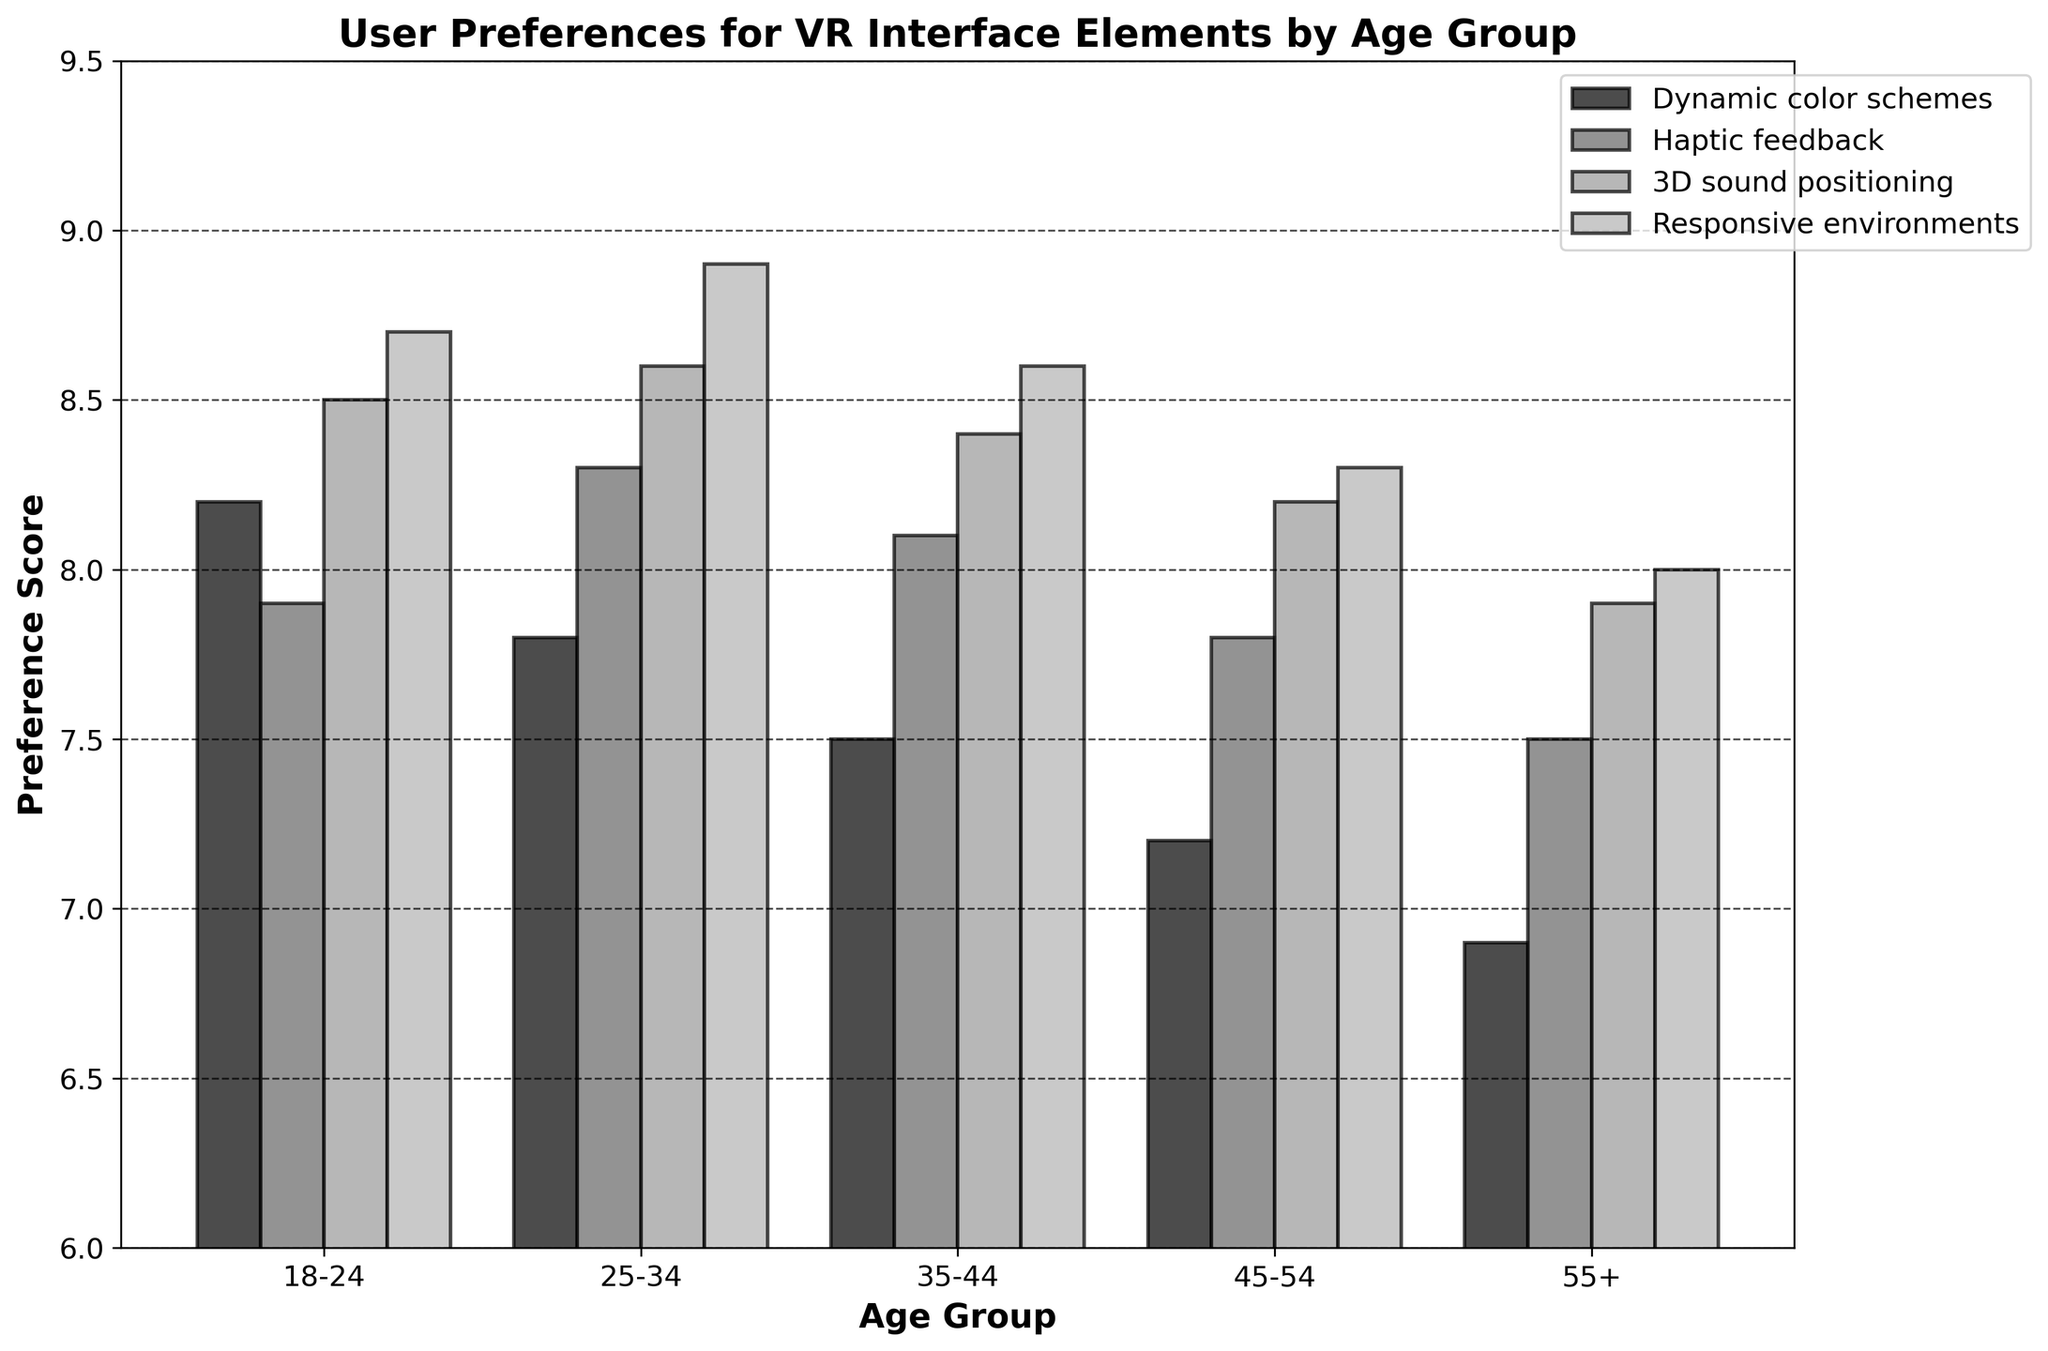Which age group has the lowest preference score for Dynamic color schemes? Look at the bars representing "Dynamic color schemes" across all age groups. The bar for the 55+ age group is the shortest.
Answer: 55+ Which interface element has the highest preference score among the 25-34 age group? Observe the bars corresponding to different interface elements for the 25-34 age group. The tallest bar represents "Responsive environments."
Answer: Responsive environments What is the difference between the preference scores for Haptic feedback for the age groups 18-24 and 55+? Compare the bars for "Haptic feedback" between these two age groups. The scores are 7.9 for 18-24 and 7.5 for 55+. Subtract 7.5 from 7.9: 7.9 - 7.5 = 0.4
Answer: 0.4 What is the average preference score for 3D sound positioning across all age groups? Add up the preference scores for "3D sound positioning" across all age groups: 8.5 (18-24) + 8.6 (25-34) + 8.4 (35-44) + 8.2 (45-54) + 7.9 (55+). Divide by 5 to find the average: (8.5 + 8.6 + 8.4 + 8.2 + 7.9) / 5 = 8.32
Answer: 8.32 Which age group has the most uniform (i.e., the smallest range) preference scores across all interface elements? Calculate the range (difference between highest and lowest scores) for each age group. For 18-24, the range is 8.7 - 7.9 = 0.8; for 25-34, it is 8.9 - 7.8 = 1.1; for 35-44, it is 8.6 - 7.5 = 1.1; for 45-54, it is 8.3 - 7.2 = 1.1; for 55+, it is 8.0 - 6.9 = 1.1. The smallest range score is for 18-24.
Answer: 18-24 Which interface element has the least variation in preference scores across all age groups? Calculate the range for each interface element by subtracting the lowest score from the highest score. For "Dynamic color schemes," the range is 8.2 - 6.9 = 1.3. For "Haptic feedback," it's 8.3 - 7.5 = 0.8. For "3D sound positioning," it's 8.6 - 7.9 = 0.7. For "Responsive environments," it's 8.9 - 8.0 = 0.9. The least variation is for "3D sound positioning."
Answer: 3D sound positioning What is the combined preference score for Dynamic color schemes and Responsive environments in the 35-44 age group? Add the preference scores for "Dynamic color schemes" and "Responsive environments" in the 35-44 age group: 7.5 + 8.6 = 16.1
Answer: 16.1 